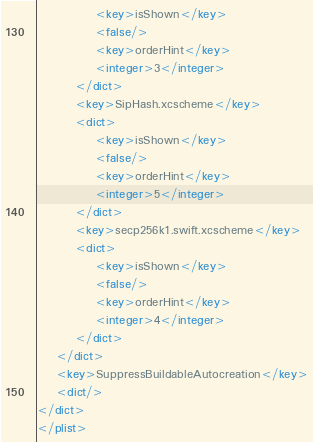Convert code to text. <code><loc_0><loc_0><loc_500><loc_500><_XML_>			<key>isShown</key>
			<false/>
			<key>orderHint</key>
			<integer>3</integer>
		</dict>
		<key>SipHash.xcscheme</key>
		<dict>
			<key>isShown</key>
			<false/>
			<key>orderHint</key>
			<integer>5</integer>
		</dict>
		<key>secp256k1.swift.xcscheme</key>
		<dict>
			<key>isShown</key>
			<false/>
			<key>orderHint</key>
			<integer>4</integer>
		</dict>
	</dict>
	<key>SuppressBuildableAutocreation</key>
	<dict/>
</dict>
</plist>
</code> 